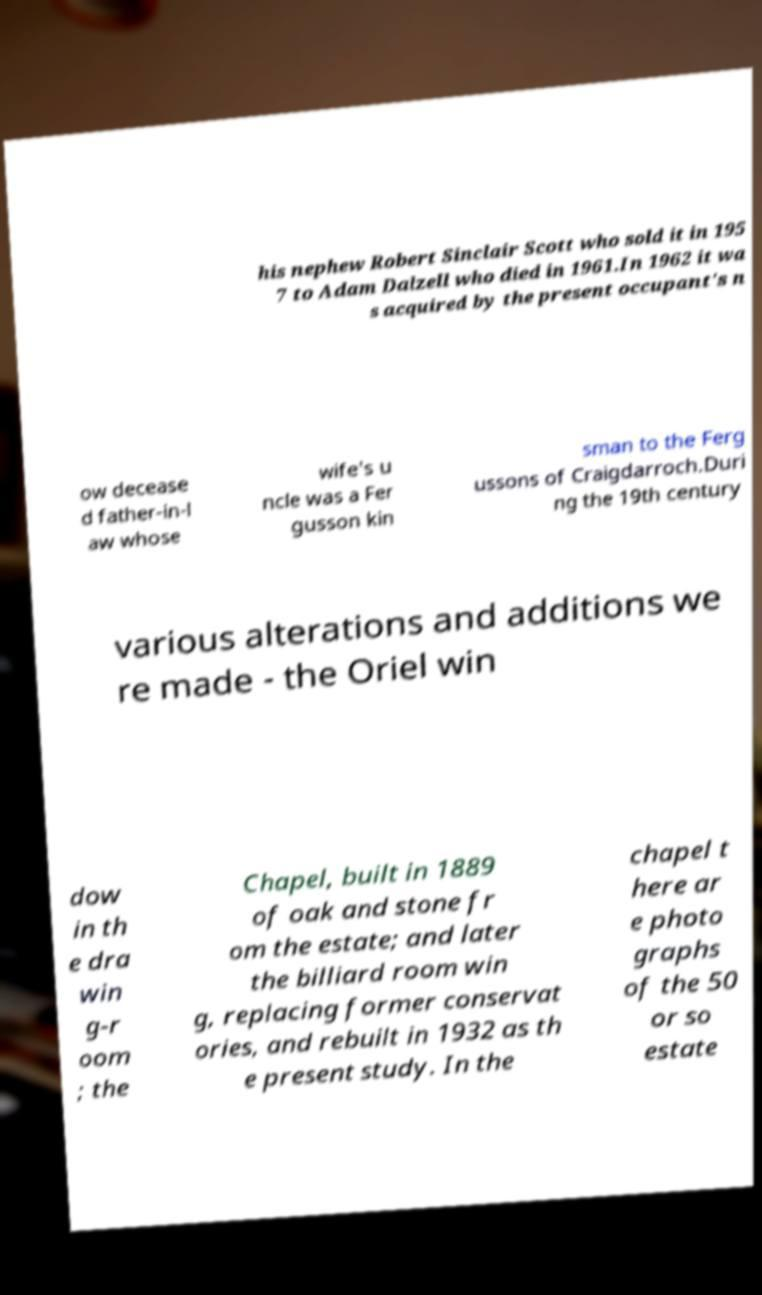Can you accurately transcribe the text from the provided image for me? his nephew Robert Sinclair Scott who sold it in 195 7 to Adam Dalzell who died in 1961.In 1962 it wa s acquired by the present occupant's n ow decease d father-in-l aw whose wife's u ncle was a Fer gusson kin sman to the Ferg ussons of Craigdarroch.Duri ng the 19th century various alterations and additions we re made - the Oriel win dow in th e dra win g-r oom ; the Chapel, built in 1889 of oak and stone fr om the estate; and later the billiard room win g, replacing former conservat ories, and rebuilt in 1932 as th e present study. In the chapel t here ar e photo graphs of the 50 or so estate 